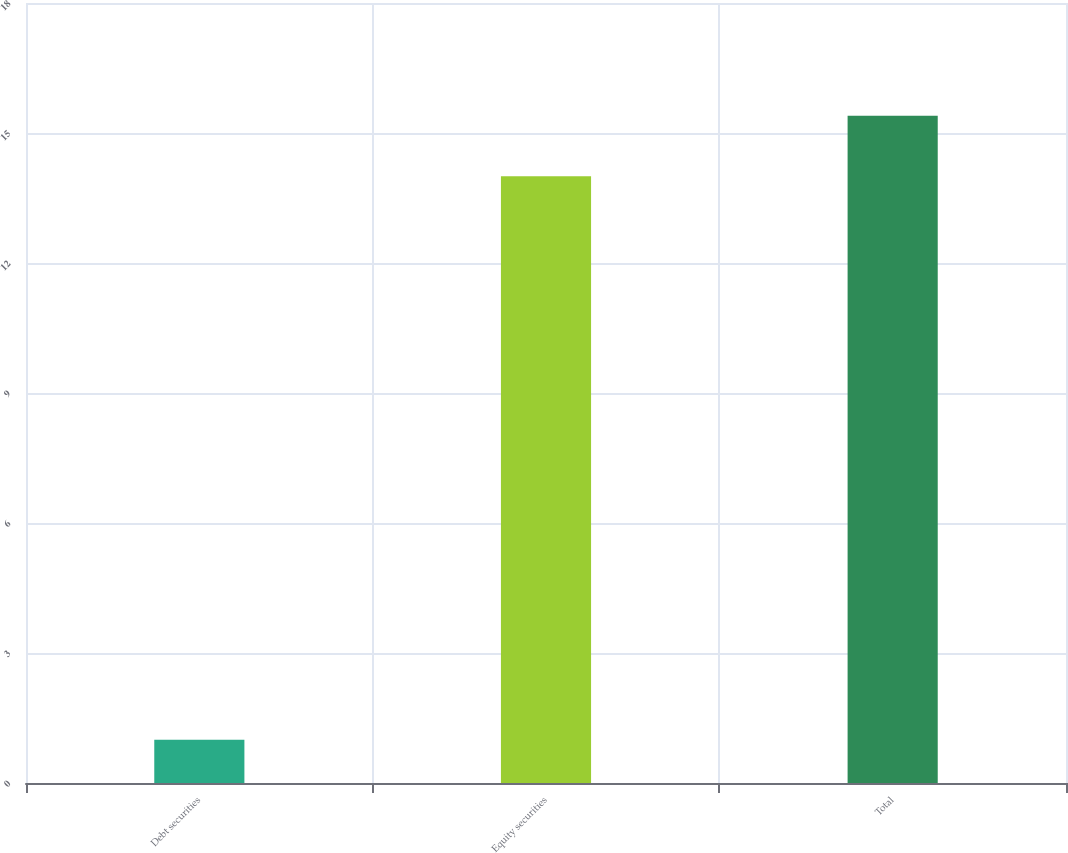Convert chart to OTSL. <chart><loc_0><loc_0><loc_500><loc_500><bar_chart><fcel>Debt securities<fcel>Equity securities<fcel>Total<nl><fcel>1<fcel>14<fcel>15.4<nl></chart> 